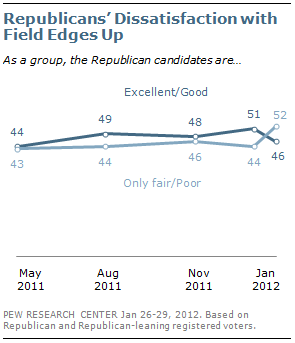Specify some key components in this picture. The occurrence of 44 data points is shown in the light blue graph, with a range of 2. The rightmost value of the "Excellent/Good" graph is 46, as stated in the question. 